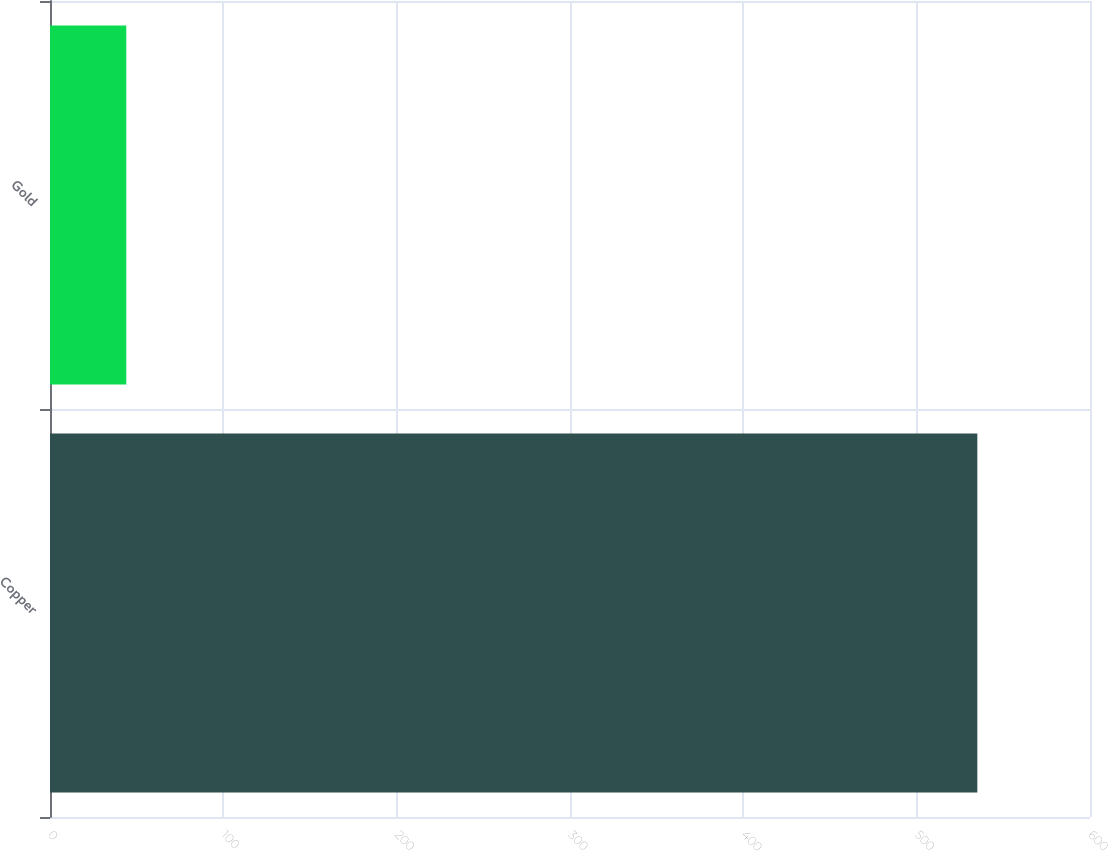<chart> <loc_0><loc_0><loc_500><loc_500><bar_chart><fcel>Copper<fcel>Gold<nl><fcel>535<fcel>44<nl></chart> 